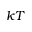Convert formula to latex. <formula><loc_0><loc_0><loc_500><loc_500>k T</formula> 